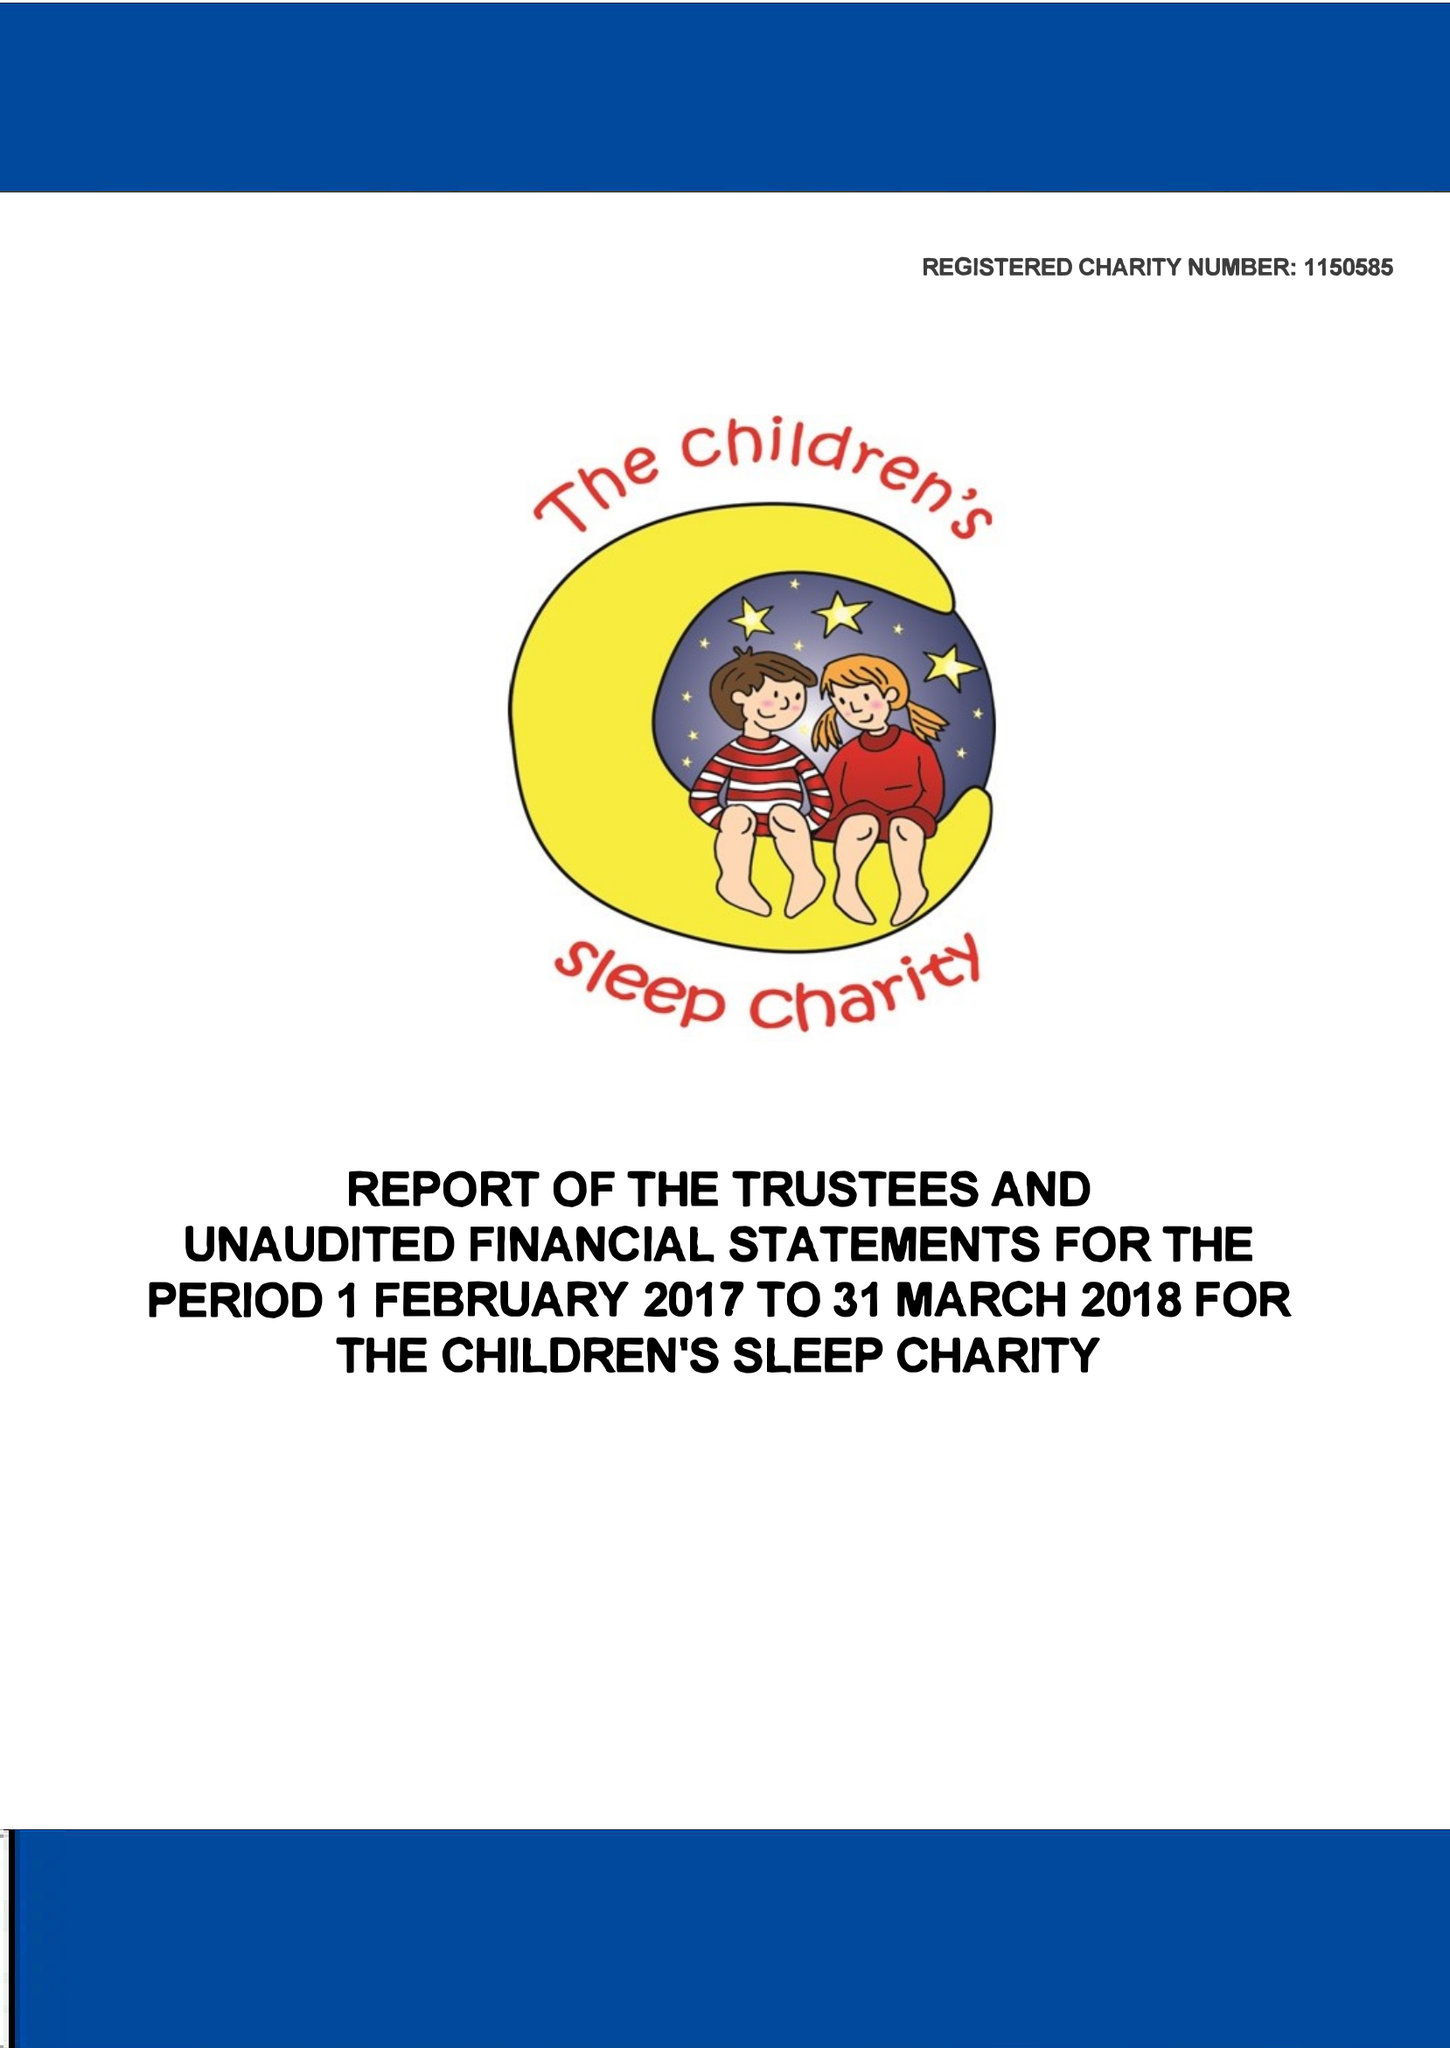What is the value for the address__street_line?
Answer the question using a single word or phrase. TICKHILL ROAD 